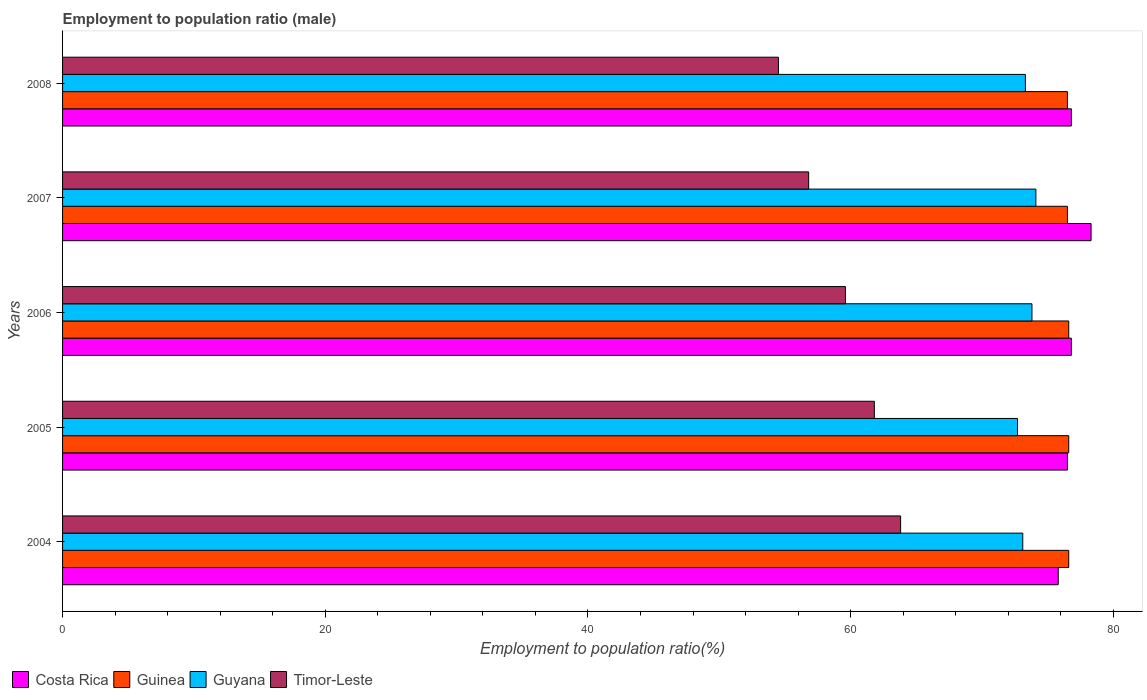How many different coloured bars are there?
Ensure brevity in your answer.  4. How many groups of bars are there?
Give a very brief answer. 5. Are the number of bars on each tick of the Y-axis equal?
Your response must be concise. Yes. How many bars are there on the 2nd tick from the bottom?
Keep it short and to the point. 4. In how many cases, is the number of bars for a given year not equal to the number of legend labels?
Ensure brevity in your answer.  0. What is the employment to population ratio in Costa Rica in 2004?
Provide a short and direct response. 75.8. Across all years, what is the maximum employment to population ratio in Timor-Leste?
Provide a succinct answer. 63.8. Across all years, what is the minimum employment to population ratio in Costa Rica?
Make the answer very short. 75.8. What is the total employment to population ratio in Guyana in the graph?
Keep it short and to the point. 367. What is the difference between the employment to population ratio in Guyana in 2004 and the employment to population ratio in Guinea in 2005?
Provide a short and direct response. -3.5. What is the average employment to population ratio in Guyana per year?
Make the answer very short. 73.4. In the year 2004, what is the difference between the employment to population ratio in Guinea and employment to population ratio in Timor-Leste?
Provide a succinct answer. 12.8. What is the ratio of the employment to population ratio in Guyana in 2005 to that in 2008?
Offer a terse response. 0.99. What is the difference between the highest and the lowest employment to population ratio in Guyana?
Offer a very short reply. 1.4. In how many years, is the employment to population ratio in Timor-Leste greater than the average employment to population ratio in Timor-Leste taken over all years?
Make the answer very short. 3. Is it the case that in every year, the sum of the employment to population ratio in Timor-Leste and employment to population ratio in Costa Rica is greater than the sum of employment to population ratio in Guyana and employment to population ratio in Guinea?
Provide a short and direct response. Yes. What does the 3rd bar from the bottom in 2006 represents?
Provide a succinct answer. Guyana. Is it the case that in every year, the sum of the employment to population ratio in Costa Rica and employment to population ratio in Guinea is greater than the employment to population ratio in Guyana?
Your answer should be compact. Yes. How many bars are there?
Give a very brief answer. 20. What is the difference between two consecutive major ticks on the X-axis?
Give a very brief answer. 20. Are the values on the major ticks of X-axis written in scientific E-notation?
Provide a succinct answer. No. Where does the legend appear in the graph?
Your answer should be very brief. Bottom left. How many legend labels are there?
Your answer should be compact. 4. How are the legend labels stacked?
Provide a succinct answer. Horizontal. What is the title of the graph?
Ensure brevity in your answer.  Employment to population ratio (male). Does "Cuba" appear as one of the legend labels in the graph?
Make the answer very short. No. What is the label or title of the X-axis?
Offer a very short reply. Employment to population ratio(%). What is the Employment to population ratio(%) of Costa Rica in 2004?
Your answer should be very brief. 75.8. What is the Employment to population ratio(%) in Guinea in 2004?
Your answer should be compact. 76.6. What is the Employment to population ratio(%) in Guyana in 2004?
Give a very brief answer. 73.1. What is the Employment to population ratio(%) of Timor-Leste in 2004?
Provide a short and direct response. 63.8. What is the Employment to population ratio(%) in Costa Rica in 2005?
Offer a very short reply. 76.5. What is the Employment to population ratio(%) in Guinea in 2005?
Provide a short and direct response. 76.6. What is the Employment to population ratio(%) of Guyana in 2005?
Your answer should be compact. 72.7. What is the Employment to population ratio(%) in Timor-Leste in 2005?
Your answer should be compact. 61.8. What is the Employment to population ratio(%) of Costa Rica in 2006?
Keep it short and to the point. 76.8. What is the Employment to population ratio(%) of Guinea in 2006?
Offer a very short reply. 76.6. What is the Employment to population ratio(%) in Guyana in 2006?
Provide a succinct answer. 73.8. What is the Employment to population ratio(%) of Timor-Leste in 2006?
Your response must be concise. 59.6. What is the Employment to population ratio(%) of Costa Rica in 2007?
Give a very brief answer. 78.3. What is the Employment to population ratio(%) in Guinea in 2007?
Your answer should be very brief. 76.5. What is the Employment to population ratio(%) of Guyana in 2007?
Make the answer very short. 74.1. What is the Employment to population ratio(%) in Timor-Leste in 2007?
Provide a succinct answer. 56.8. What is the Employment to population ratio(%) of Costa Rica in 2008?
Make the answer very short. 76.8. What is the Employment to population ratio(%) of Guinea in 2008?
Make the answer very short. 76.5. What is the Employment to population ratio(%) of Guyana in 2008?
Provide a succinct answer. 73.3. What is the Employment to population ratio(%) of Timor-Leste in 2008?
Offer a very short reply. 54.5. Across all years, what is the maximum Employment to population ratio(%) of Costa Rica?
Ensure brevity in your answer.  78.3. Across all years, what is the maximum Employment to population ratio(%) of Guinea?
Offer a terse response. 76.6. Across all years, what is the maximum Employment to population ratio(%) of Guyana?
Your response must be concise. 74.1. Across all years, what is the maximum Employment to population ratio(%) of Timor-Leste?
Your response must be concise. 63.8. Across all years, what is the minimum Employment to population ratio(%) in Costa Rica?
Make the answer very short. 75.8. Across all years, what is the minimum Employment to population ratio(%) in Guinea?
Your answer should be compact. 76.5. Across all years, what is the minimum Employment to population ratio(%) of Guyana?
Make the answer very short. 72.7. Across all years, what is the minimum Employment to population ratio(%) of Timor-Leste?
Offer a terse response. 54.5. What is the total Employment to population ratio(%) of Costa Rica in the graph?
Provide a succinct answer. 384.2. What is the total Employment to population ratio(%) in Guinea in the graph?
Your response must be concise. 382.8. What is the total Employment to population ratio(%) in Guyana in the graph?
Ensure brevity in your answer.  367. What is the total Employment to population ratio(%) of Timor-Leste in the graph?
Your answer should be compact. 296.5. What is the difference between the Employment to population ratio(%) in Costa Rica in 2004 and that in 2005?
Keep it short and to the point. -0.7. What is the difference between the Employment to population ratio(%) in Guyana in 2004 and that in 2005?
Make the answer very short. 0.4. What is the difference between the Employment to population ratio(%) of Costa Rica in 2004 and that in 2006?
Your answer should be compact. -1. What is the difference between the Employment to population ratio(%) in Guinea in 2004 and that in 2006?
Your answer should be very brief. 0. What is the difference between the Employment to population ratio(%) of Guyana in 2004 and that in 2006?
Your answer should be very brief. -0.7. What is the difference between the Employment to population ratio(%) in Guinea in 2004 and that in 2007?
Offer a very short reply. 0.1. What is the difference between the Employment to population ratio(%) of Guyana in 2004 and that in 2007?
Offer a very short reply. -1. What is the difference between the Employment to population ratio(%) of Timor-Leste in 2004 and that in 2007?
Offer a very short reply. 7. What is the difference between the Employment to population ratio(%) in Guyana in 2004 and that in 2008?
Keep it short and to the point. -0.2. What is the difference between the Employment to population ratio(%) in Costa Rica in 2005 and that in 2006?
Keep it short and to the point. -0.3. What is the difference between the Employment to population ratio(%) of Guinea in 2005 and that in 2006?
Your answer should be compact. 0. What is the difference between the Employment to population ratio(%) in Timor-Leste in 2005 and that in 2006?
Give a very brief answer. 2.2. What is the difference between the Employment to population ratio(%) in Guinea in 2005 and that in 2007?
Your response must be concise. 0.1. What is the difference between the Employment to population ratio(%) of Guyana in 2005 and that in 2007?
Offer a terse response. -1.4. What is the difference between the Employment to population ratio(%) of Costa Rica in 2005 and that in 2008?
Offer a terse response. -0.3. What is the difference between the Employment to population ratio(%) in Guinea in 2005 and that in 2008?
Provide a succinct answer. 0.1. What is the difference between the Employment to population ratio(%) in Timor-Leste in 2005 and that in 2008?
Your answer should be very brief. 7.3. What is the difference between the Employment to population ratio(%) in Guinea in 2006 and that in 2007?
Offer a terse response. 0.1. What is the difference between the Employment to population ratio(%) in Guyana in 2006 and that in 2007?
Ensure brevity in your answer.  -0.3. What is the difference between the Employment to population ratio(%) of Timor-Leste in 2006 and that in 2007?
Provide a succinct answer. 2.8. What is the difference between the Employment to population ratio(%) of Costa Rica in 2006 and that in 2008?
Your answer should be very brief. 0. What is the difference between the Employment to population ratio(%) in Guinea in 2006 and that in 2008?
Offer a terse response. 0.1. What is the difference between the Employment to population ratio(%) in Guyana in 2007 and that in 2008?
Your answer should be compact. 0.8. What is the difference between the Employment to population ratio(%) of Guinea in 2004 and the Employment to population ratio(%) of Guyana in 2005?
Keep it short and to the point. 3.9. What is the difference between the Employment to population ratio(%) in Costa Rica in 2004 and the Employment to population ratio(%) in Guinea in 2006?
Your answer should be very brief. -0.8. What is the difference between the Employment to population ratio(%) of Costa Rica in 2004 and the Employment to population ratio(%) of Timor-Leste in 2006?
Ensure brevity in your answer.  16.2. What is the difference between the Employment to population ratio(%) of Guyana in 2004 and the Employment to population ratio(%) of Timor-Leste in 2006?
Make the answer very short. 13.5. What is the difference between the Employment to population ratio(%) in Costa Rica in 2004 and the Employment to population ratio(%) in Guinea in 2007?
Give a very brief answer. -0.7. What is the difference between the Employment to population ratio(%) of Guinea in 2004 and the Employment to population ratio(%) of Guyana in 2007?
Your response must be concise. 2.5. What is the difference between the Employment to population ratio(%) of Guinea in 2004 and the Employment to population ratio(%) of Timor-Leste in 2007?
Ensure brevity in your answer.  19.8. What is the difference between the Employment to population ratio(%) in Guyana in 2004 and the Employment to population ratio(%) in Timor-Leste in 2007?
Give a very brief answer. 16.3. What is the difference between the Employment to population ratio(%) in Costa Rica in 2004 and the Employment to population ratio(%) in Guyana in 2008?
Provide a succinct answer. 2.5. What is the difference between the Employment to population ratio(%) of Costa Rica in 2004 and the Employment to population ratio(%) of Timor-Leste in 2008?
Your answer should be very brief. 21.3. What is the difference between the Employment to population ratio(%) in Guinea in 2004 and the Employment to population ratio(%) in Timor-Leste in 2008?
Offer a very short reply. 22.1. What is the difference between the Employment to population ratio(%) of Costa Rica in 2005 and the Employment to population ratio(%) of Guinea in 2006?
Offer a very short reply. -0.1. What is the difference between the Employment to population ratio(%) in Costa Rica in 2005 and the Employment to population ratio(%) in Guyana in 2006?
Offer a terse response. 2.7. What is the difference between the Employment to population ratio(%) in Costa Rica in 2005 and the Employment to population ratio(%) in Timor-Leste in 2006?
Your answer should be compact. 16.9. What is the difference between the Employment to population ratio(%) in Guinea in 2005 and the Employment to population ratio(%) in Guyana in 2006?
Ensure brevity in your answer.  2.8. What is the difference between the Employment to population ratio(%) of Guyana in 2005 and the Employment to population ratio(%) of Timor-Leste in 2006?
Keep it short and to the point. 13.1. What is the difference between the Employment to population ratio(%) in Costa Rica in 2005 and the Employment to population ratio(%) in Guyana in 2007?
Provide a succinct answer. 2.4. What is the difference between the Employment to population ratio(%) of Guinea in 2005 and the Employment to population ratio(%) of Timor-Leste in 2007?
Offer a terse response. 19.8. What is the difference between the Employment to population ratio(%) in Guinea in 2005 and the Employment to population ratio(%) in Guyana in 2008?
Keep it short and to the point. 3.3. What is the difference between the Employment to population ratio(%) in Guinea in 2005 and the Employment to population ratio(%) in Timor-Leste in 2008?
Offer a terse response. 22.1. What is the difference between the Employment to population ratio(%) of Costa Rica in 2006 and the Employment to population ratio(%) of Guyana in 2007?
Your response must be concise. 2.7. What is the difference between the Employment to population ratio(%) in Costa Rica in 2006 and the Employment to population ratio(%) in Timor-Leste in 2007?
Keep it short and to the point. 20. What is the difference between the Employment to population ratio(%) of Guinea in 2006 and the Employment to population ratio(%) of Guyana in 2007?
Provide a short and direct response. 2.5. What is the difference between the Employment to population ratio(%) of Guinea in 2006 and the Employment to population ratio(%) of Timor-Leste in 2007?
Your answer should be very brief. 19.8. What is the difference between the Employment to population ratio(%) of Costa Rica in 2006 and the Employment to population ratio(%) of Guinea in 2008?
Ensure brevity in your answer.  0.3. What is the difference between the Employment to population ratio(%) of Costa Rica in 2006 and the Employment to population ratio(%) of Timor-Leste in 2008?
Offer a terse response. 22.3. What is the difference between the Employment to population ratio(%) of Guinea in 2006 and the Employment to population ratio(%) of Timor-Leste in 2008?
Your answer should be compact. 22.1. What is the difference between the Employment to population ratio(%) in Guyana in 2006 and the Employment to population ratio(%) in Timor-Leste in 2008?
Provide a short and direct response. 19.3. What is the difference between the Employment to population ratio(%) in Costa Rica in 2007 and the Employment to population ratio(%) in Timor-Leste in 2008?
Your response must be concise. 23.8. What is the difference between the Employment to population ratio(%) in Guinea in 2007 and the Employment to population ratio(%) in Guyana in 2008?
Your answer should be very brief. 3.2. What is the difference between the Employment to population ratio(%) of Guinea in 2007 and the Employment to population ratio(%) of Timor-Leste in 2008?
Your response must be concise. 22. What is the difference between the Employment to population ratio(%) of Guyana in 2007 and the Employment to population ratio(%) of Timor-Leste in 2008?
Your response must be concise. 19.6. What is the average Employment to population ratio(%) in Costa Rica per year?
Make the answer very short. 76.84. What is the average Employment to population ratio(%) in Guinea per year?
Give a very brief answer. 76.56. What is the average Employment to population ratio(%) of Guyana per year?
Make the answer very short. 73.4. What is the average Employment to population ratio(%) of Timor-Leste per year?
Provide a succinct answer. 59.3. In the year 2004, what is the difference between the Employment to population ratio(%) in Costa Rica and Employment to population ratio(%) in Guinea?
Keep it short and to the point. -0.8. In the year 2004, what is the difference between the Employment to population ratio(%) in Costa Rica and Employment to population ratio(%) in Guyana?
Offer a very short reply. 2.7. In the year 2004, what is the difference between the Employment to population ratio(%) in Guinea and Employment to population ratio(%) in Guyana?
Make the answer very short. 3.5. In the year 2004, what is the difference between the Employment to population ratio(%) in Guinea and Employment to population ratio(%) in Timor-Leste?
Give a very brief answer. 12.8. In the year 2004, what is the difference between the Employment to population ratio(%) of Guyana and Employment to population ratio(%) of Timor-Leste?
Offer a terse response. 9.3. In the year 2005, what is the difference between the Employment to population ratio(%) of Costa Rica and Employment to population ratio(%) of Guinea?
Your answer should be compact. -0.1. In the year 2005, what is the difference between the Employment to population ratio(%) in Costa Rica and Employment to population ratio(%) in Guyana?
Your answer should be compact. 3.8. In the year 2005, what is the difference between the Employment to population ratio(%) in Costa Rica and Employment to population ratio(%) in Timor-Leste?
Your response must be concise. 14.7. In the year 2005, what is the difference between the Employment to population ratio(%) in Guinea and Employment to population ratio(%) in Guyana?
Provide a succinct answer. 3.9. In the year 2005, what is the difference between the Employment to population ratio(%) in Guinea and Employment to population ratio(%) in Timor-Leste?
Offer a very short reply. 14.8. In the year 2006, what is the difference between the Employment to population ratio(%) in Costa Rica and Employment to population ratio(%) in Timor-Leste?
Provide a short and direct response. 17.2. In the year 2006, what is the difference between the Employment to population ratio(%) in Guinea and Employment to population ratio(%) in Guyana?
Offer a terse response. 2.8. In the year 2007, what is the difference between the Employment to population ratio(%) in Costa Rica and Employment to population ratio(%) in Guinea?
Ensure brevity in your answer.  1.8. In the year 2007, what is the difference between the Employment to population ratio(%) of Costa Rica and Employment to population ratio(%) of Timor-Leste?
Offer a terse response. 21.5. In the year 2007, what is the difference between the Employment to population ratio(%) in Guinea and Employment to population ratio(%) in Timor-Leste?
Provide a succinct answer. 19.7. In the year 2008, what is the difference between the Employment to population ratio(%) of Costa Rica and Employment to population ratio(%) of Guinea?
Ensure brevity in your answer.  0.3. In the year 2008, what is the difference between the Employment to population ratio(%) of Costa Rica and Employment to population ratio(%) of Timor-Leste?
Ensure brevity in your answer.  22.3. In the year 2008, what is the difference between the Employment to population ratio(%) of Guyana and Employment to population ratio(%) of Timor-Leste?
Ensure brevity in your answer.  18.8. What is the ratio of the Employment to population ratio(%) of Costa Rica in 2004 to that in 2005?
Ensure brevity in your answer.  0.99. What is the ratio of the Employment to population ratio(%) of Guinea in 2004 to that in 2005?
Provide a short and direct response. 1. What is the ratio of the Employment to population ratio(%) of Guyana in 2004 to that in 2005?
Your response must be concise. 1.01. What is the ratio of the Employment to population ratio(%) in Timor-Leste in 2004 to that in 2005?
Give a very brief answer. 1.03. What is the ratio of the Employment to population ratio(%) of Guinea in 2004 to that in 2006?
Keep it short and to the point. 1. What is the ratio of the Employment to population ratio(%) of Guyana in 2004 to that in 2006?
Provide a succinct answer. 0.99. What is the ratio of the Employment to population ratio(%) in Timor-Leste in 2004 to that in 2006?
Make the answer very short. 1.07. What is the ratio of the Employment to population ratio(%) in Costa Rica in 2004 to that in 2007?
Give a very brief answer. 0.97. What is the ratio of the Employment to population ratio(%) in Guyana in 2004 to that in 2007?
Provide a succinct answer. 0.99. What is the ratio of the Employment to population ratio(%) of Timor-Leste in 2004 to that in 2007?
Ensure brevity in your answer.  1.12. What is the ratio of the Employment to population ratio(%) of Costa Rica in 2004 to that in 2008?
Keep it short and to the point. 0.99. What is the ratio of the Employment to population ratio(%) in Guinea in 2004 to that in 2008?
Your answer should be very brief. 1. What is the ratio of the Employment to population ratio(%) in Timor-Leste in 2004 to that in 2008?
Your answer should be compact. 1.17. What is the ratio of the Employment to population ratio(%) of Costa Rica in 2005 to that in 2006?
Make the answer very short. 1. What is the ratio of the Employment to population ratio(%) of Guinea in 2005 to that in 2006?
Offer a very short reply. 1. What is the ratio of the Employment to population ratio(%) of Guyana in 2005 to that in 2006?
Your answer should be compact. 0.99. What is the ratio of the Employment to population ratio(%) in Timor-Leste in 2005 to that in 2006?
Provide a succinct answer. 1.04. What is the ratio of the Employment to population ratio(%) in Costa Rica in 2005 to that in 2007?
Give a very brief answer. 0.98. What is the ratio of the Employment to population ratio(%) in Guyana in 2005 to that in 2007?
Make the answer very short. 0.98. What is the ratio of the Employment to population ratio(%) in Timor-Leste in 2005 to that in 2007?
Your response must be concise. 1.09. What is the ratio of the Employment to population ratio(%) in Costa Rica in 2005 to that in 2008?
Offer a very short reply. 1. What is the ratio of the Employment to population ratio(%) of Guyana in 2005 to that in 2008?
Provide a succinct answer. 0.99. What is the ratio of the Employment to population ratio(%) in Timor-Leste in 2005 to that in 2008?
Keep it short and to the point. 1.13. What is the ratio of the Employment to population ratio(%) in Costa Rica in 2006 to that in 2007?
Offer a very short reply. 0.98. What is the ratio of the Employment to population ratio(%) of Guyana in 2006 to that in 2007?
Give a very brief answer. 1. What is the ratio of the Employment to population ratio(%) of Timor-Leste in 2006 to that in 2007?
Provide a short and direct response. 1.05. What is the ratio of the Employment to population ratio(%) in Costa Rica in 2006 to that in 2008?
Your answer should be compact. 1. What is the ratio of the Employment to population ratio(%) in Guinea in 2006 to that in 2008?
Your response must be concise. 1. What is the ratio of the Employment to population ratio(%) in Guyana in 2006 to that in 2008?
Your answer should be very brief. 1.01. What is the ratio of the Employment to population ratio(%) of Timor-Leste in 2006 to that in 2008?
Ensure brevity in your answer.  1.09. What is the ratio of the Employment to population ratio(%) in Costa Rica in 2007 to that in 2008?
Your answer should be compact. 1.02. What is the ratio of the Employment to population ratio(%) of Guinea in 2007 to that in 2008?
Your answer should be very brief. 1. What is the ratio of the Employment to population ratio(%) of Guyana in 2007 to that in 2008?
Your response must be concise. 1.01. What is the ratio of the Employment to population ratio(%) of Timor-Leste in 2007 to that in 2008?
Provide a succinct answer. 1.04. What is the difference between the highest and the second highest Employment to population ratio(%) of Costa Rica?
Make the answer very short. 1.5. What is the difference between the highest and the second highest Employment to population ratio(%) in Guinea?
Offer a terse response. 0. What is the difference between the highest and the second highest Employment to population ratio(%) in Guyana?
Your answer should be very brief. 0.3. What is the difference between the highest and the second highest Employment to population ratio(%) of Timor-Leste?
Offer a very short reply. 2. What is the difference between the highest and the lowest Employment to population ratio(%) in Guinea?
Provide a short and direct response. 0.1. What is the difference between the highest and the lowest Employment to population ratio(%) in Guyana?
Provide a short and direct response. 1.4. What is the difference between the highest and the lowest Employment to population ratio(%) in Timor-Leste?
Provide a succinct answer. 9.3. 